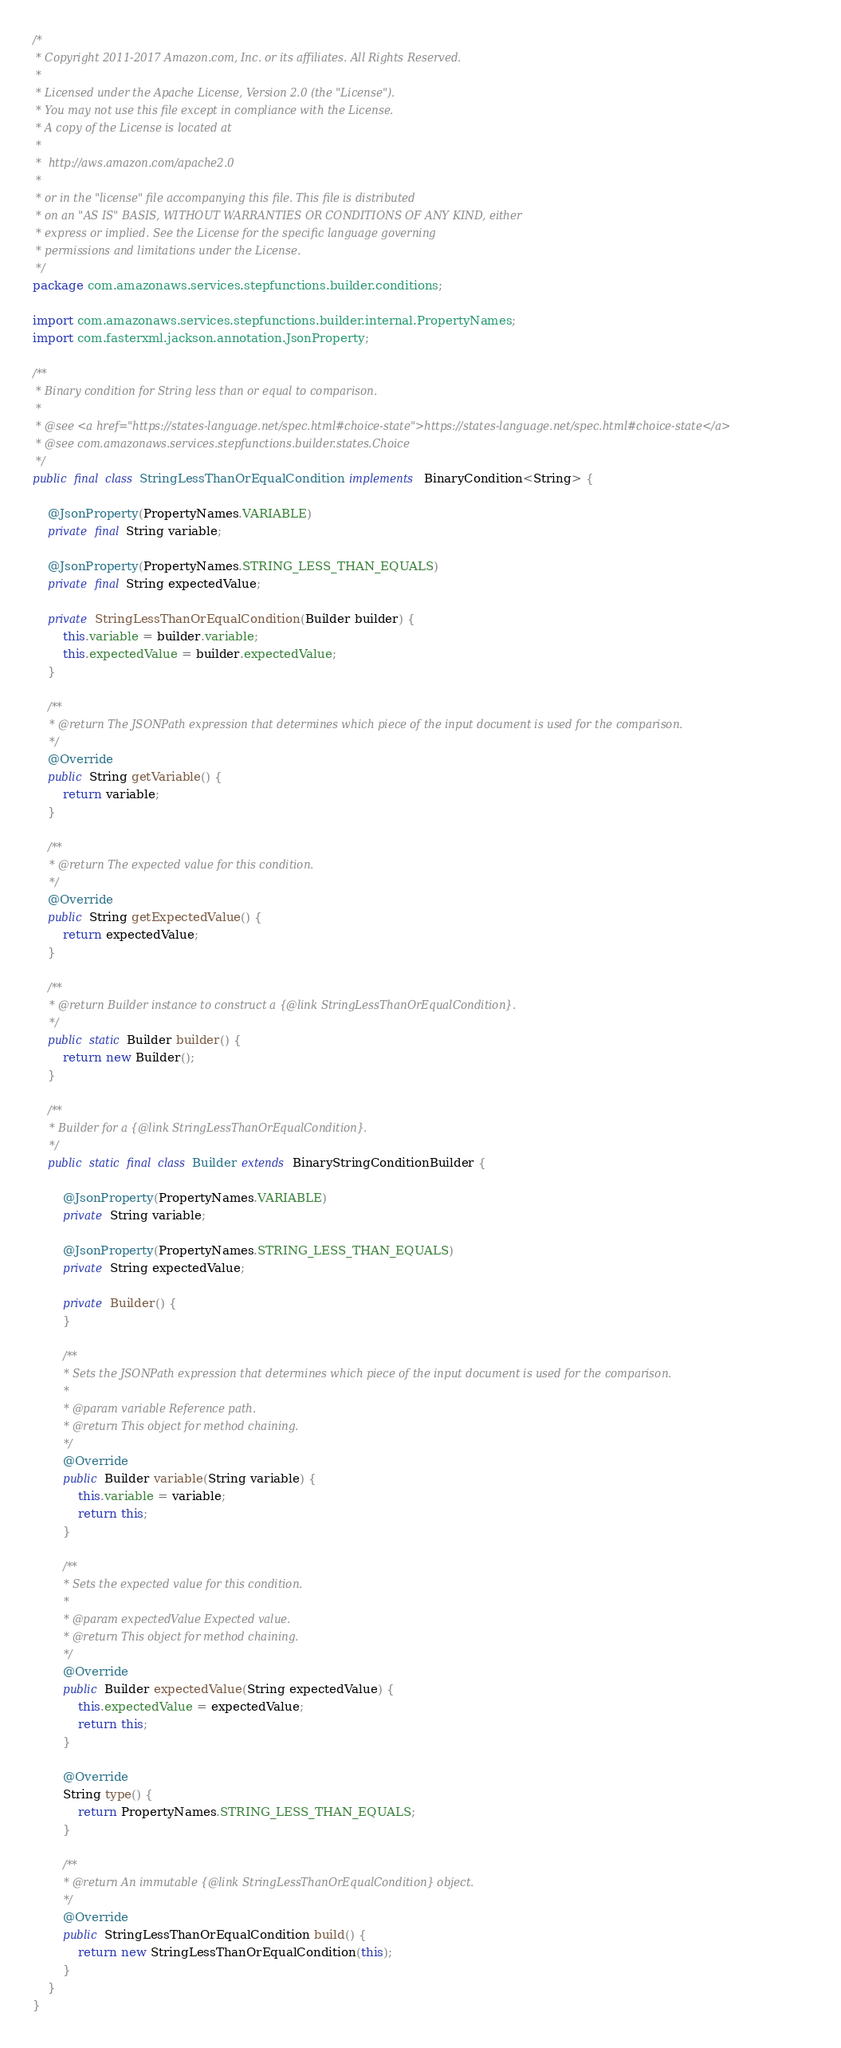<code> <loc_0><loc_0><loc_500><loc_500><_Java_>/*
 * Copyright 2011-2017 Amazon.com, Inc. or its affiliates. All Rights Reserved.
 *
 * Licensed under the Apache License, Version 2.0 (the "License").
 * You may not use this file except in compliance with the License.
 * A copy of the License is located at
 *
 *  http://aws.amazon.com/apache2.0
 *
 * or in the "license" file accompanying this file. This file is distributed
 * on an "AS IS" BASIS, WITHOUT WARRANTIES OR CONDITIONS OF ANY KIND, either
 * express or implied. See the License for the specific language governing
 * permissions and limitations under the License.
 */
package com.amazonaws.services.stepfunctions.builder.conditions;

import com.amazonaws.services.stepfunctions.builder.internal.PropertyNames;
import com.fasterxml.jackson.annotation.JsonProperty;

/**
 * Binary condition for String less than or equal to comparison.
 *
 * @see <a href="https://states-language.net/spec.html#choice-state">https://states-language.net/spec.html#choice-state</a>
 * @see com.amazonaws.services.stepfunctions.builder.states.Choice
 */
public final class StringLessThanOrEqualCondition implements BinaryCondition<String> {

    @JsonProperty(PropertyNames.VARIABLE)
    private final String variable;

    @JsonProperty(PropertyNames.STRING_LESS_THAN_EQUALS)
    private final String expectedValue;

    private StringLessThanOrEqualCondition(Builder builder) {
        this.variable = builder.variable;
        this.expectedValue = builder.expectedValue;
    }

    /**
     * @return The JSONPath expression that determines which piece of the input document is used for the comparison.
     */
    @Override
    public String getVariable() {
        return variable;
    }

    /**
     * @return The expected value for this condition.
     */
    @Override
    public String getExpectedValue() {
        return expectedValue;
    }

    /**
     * @return Builder instance to construct a {@link StringLessThanOrEqualCondition}.
     */
    public static Builder builder() {
        return new Builder();
    }

    /**
     * Builder for a {@link StringLessThanOrEqualCondition}.
     */
    public static final class Builder extends BinaryStringConditionBuilder {

        @JsonProperty(PropertyNames.VARIABLE)
        private String variable;

        @JsonProperty(PropertyNames.STRING_LESS_THAN_EQUALS)
        private String expectedValue;

        private Builder() {
        }

        /**
         * Sets the JSONPath expression that determines which piece of the input document is used for the comparison.
         *
         * @param variable Reference path.
         * @return This object for method chaining.
         */
        @Override
        public Builder variable(String variable) {
            this.variable = variable;
            return this;
        }

        /**
         * Sets the expected value for this condition.
         *
         * @param expectedValue Expected value.
         * @return This object for method chaining.
         */
        @Override
        public Builder expectedValue(String expectedValue) {
            this.expectedValue = expectedValue;
            return this;
        }

        @Override
        String type() {
            return PropertyNames.STRING_LESS_THAN_EQUALS;
        }

        /**
         * @return An immutable {@link StringLessThanOrEqualCondition} object.
         */
        @Override
        public StringLessThanOrEqualCondition build() {
            return new StringLessThanOrEqualCondition(this);
        }
    }
}
</code> 